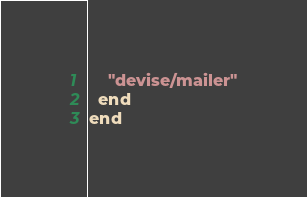<code> <loc_0><loc_0><loc_500><loc_500><_Ruby_>    "devise/mailer"
  end
end</code> 